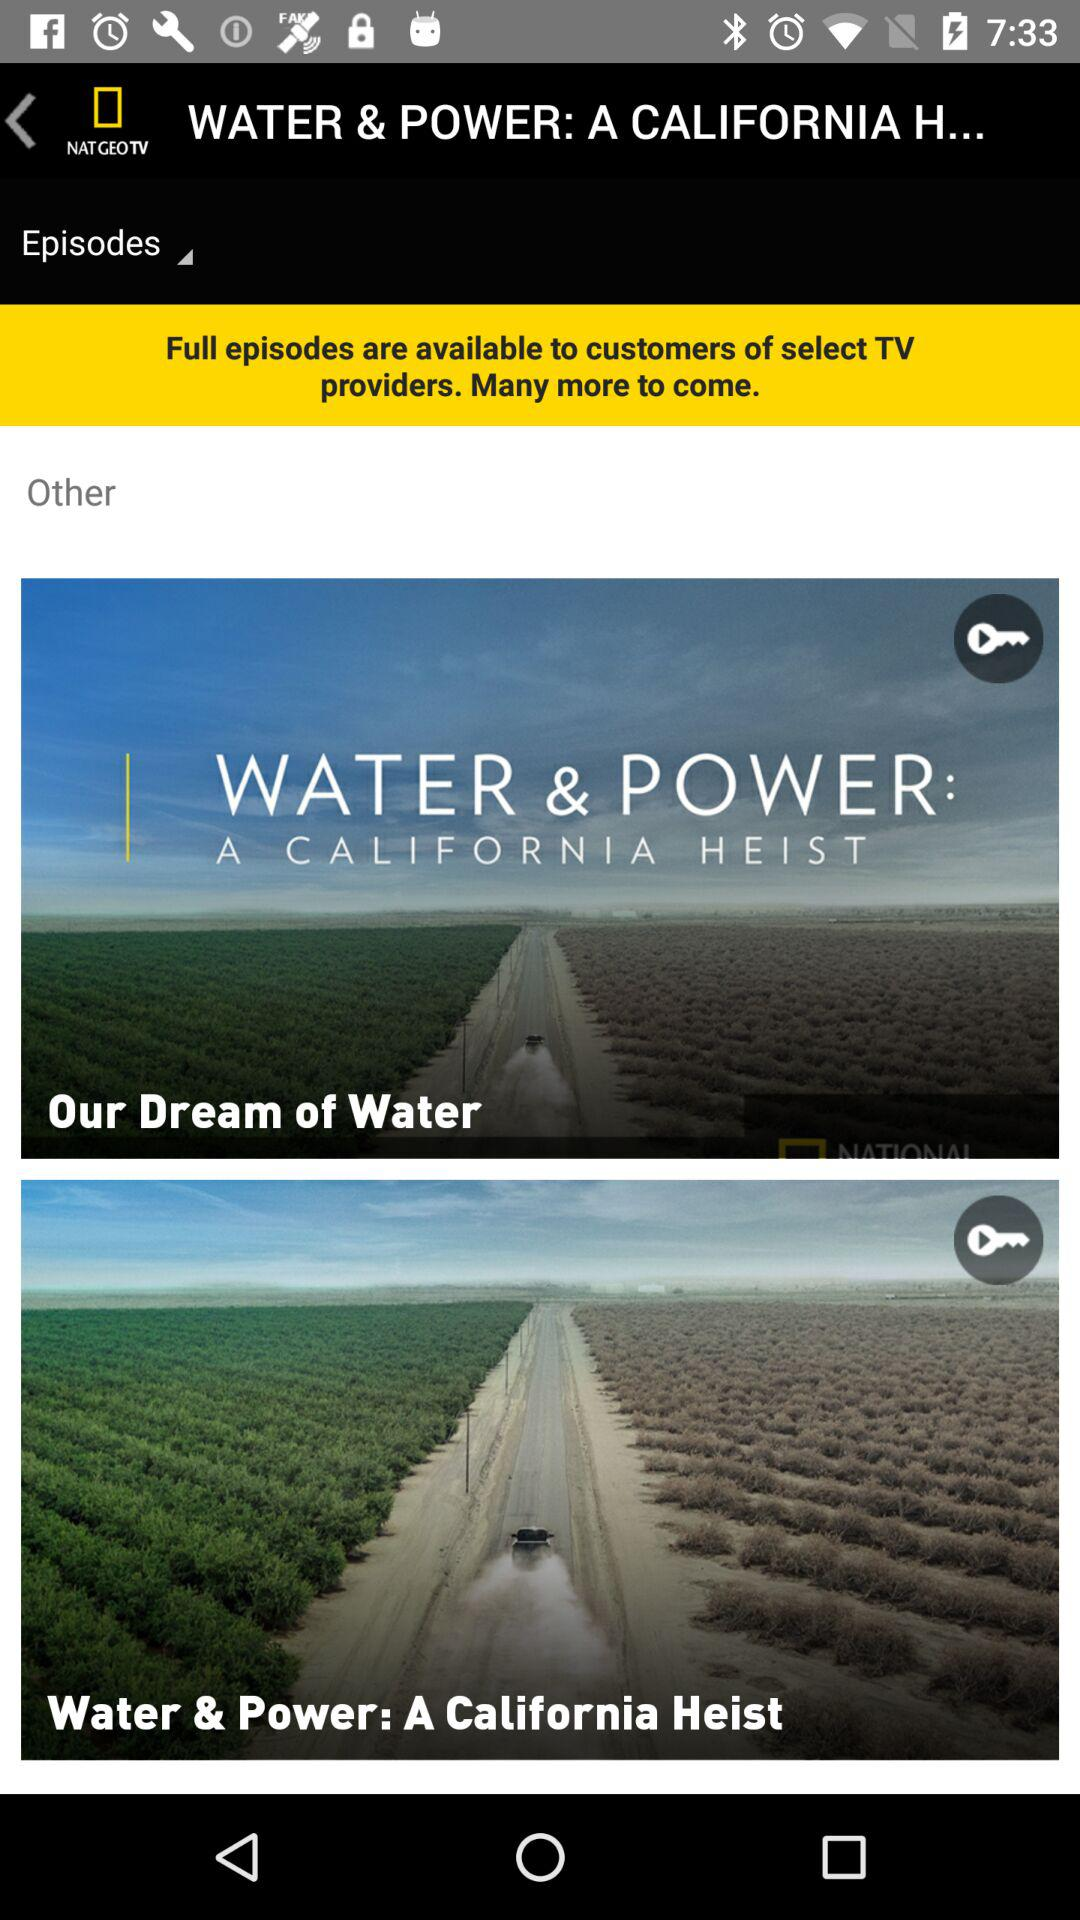What is the channel name where full episodes are available? The channel name where full episodes are available is "NAT GEO TV". 